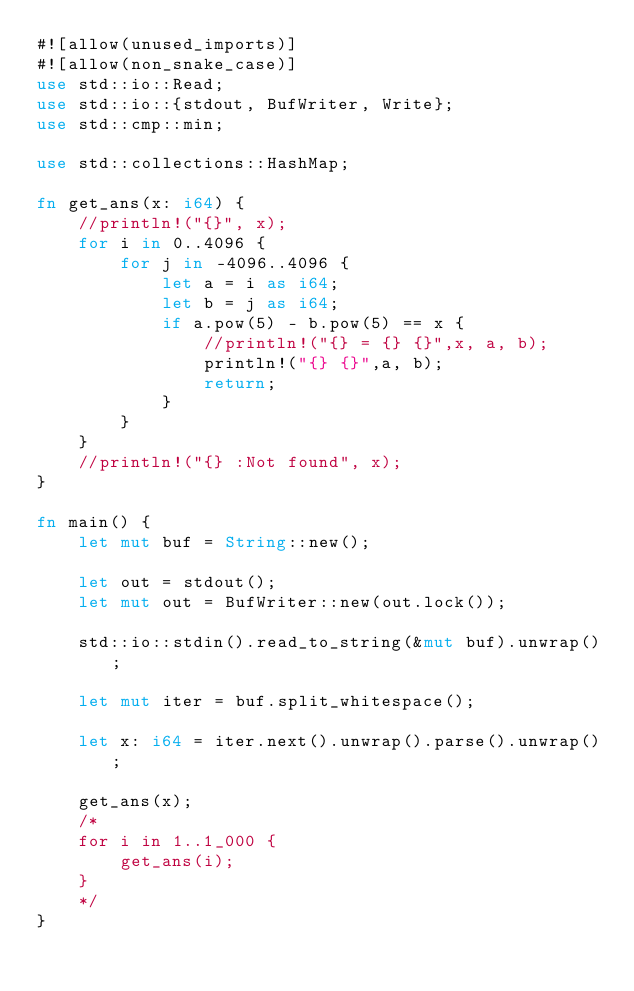<code> <loc_0><loc_0><loc_500><loc_500><_Rust_>#![allow(unused_imports)]
#![allow(non_snake_case)]
use std::io::Read;
use std::io::{stdout, BufWriter, Write};
use std::cmp::min;

use std::collections::HashMap;

fn get_ans(x: i64) {
    //println!("{}", x);
    for i in 0..4096 {
        for j in -4096..4096 {
            let a = i as i64;
            let b = j as i64;
            if a.pow(5) - b.pow(5) == x {
                //println!("{} = {} {}",x, a, b);
                println!("{} {}",a, b);
                return;
            }
        }
    }
    //println!("{} :Not found", x);
}
 
fn main() {
    let mut buf = String::new();
    
    let out = stdout();
    let mut out = BufWriter::new(out.lock());
 
    std::io::stdin().read_to_string(&mut buf).unwrap();
 
    let mut iter = buf.split_whitespace();
 
    let x: i64 = iter.next().unwrap().parse().unwrap();
    
    get_ans(x);
    /*
    for i in 1..1_000 {
        get_ans(i);
    }
    */
}</code> 